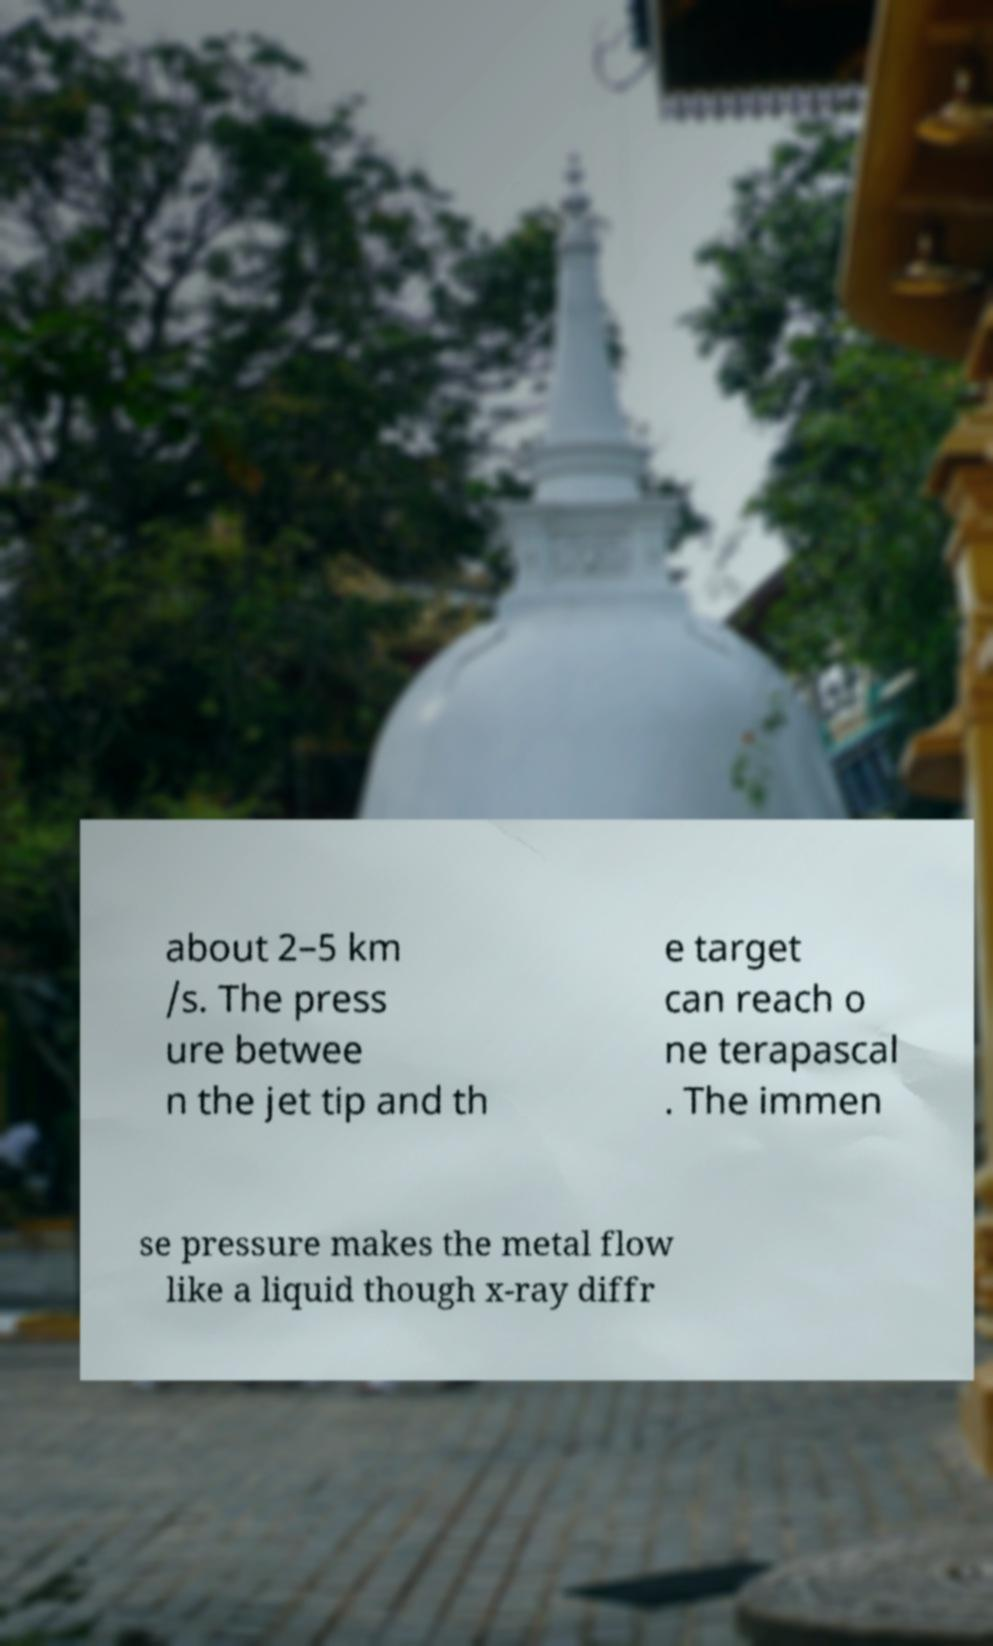There's text embedded in this image that I need extracted. Can you transcribe it verbatim? about 2–5 km /s. The press ure betwee n the jet tip and th e target can reach o ne terapascal . The immen se pressure makes the metal flow like a liquid though x-ray diffr 